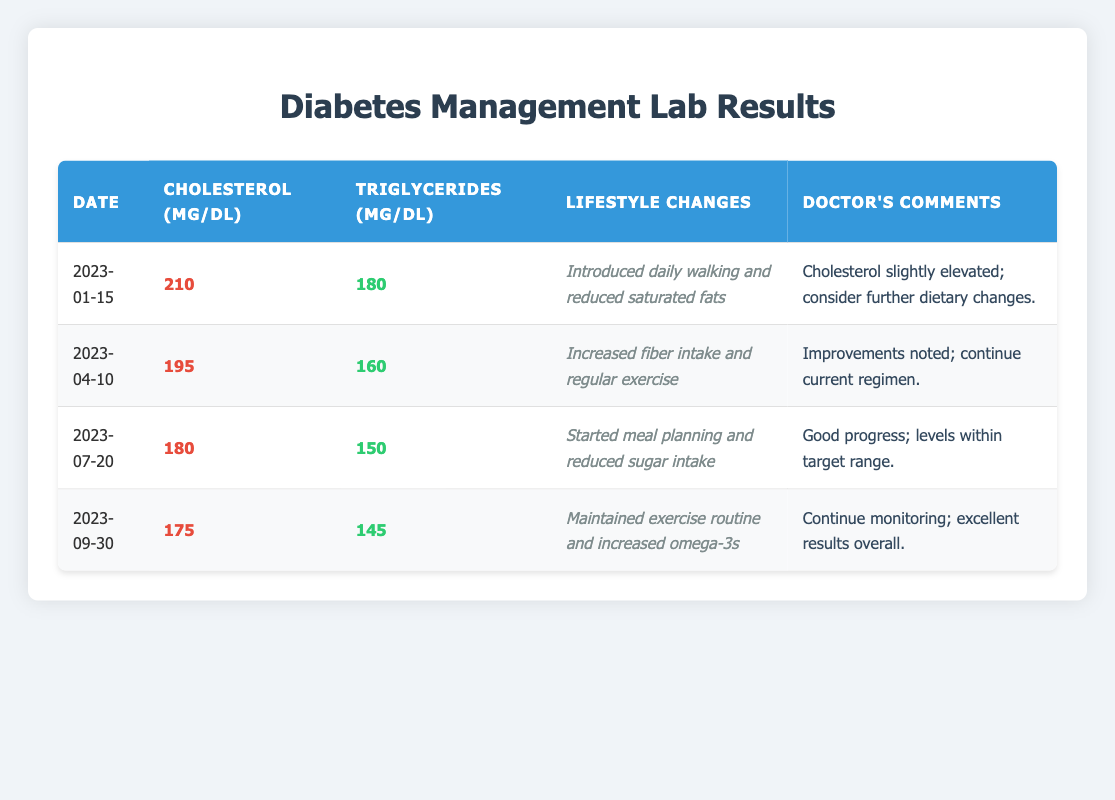What was the cholesterol level on January 15, 2023? Looking at the first row of the table, the cholesterol level recorded on January 15, 2023, is explicitly noted as 210 mg/dL.
Answer: 210 mg/dL What lifestyle changes were made on July 20, 2023? In the row for July 20, 2023, the lifestyle changes are stated to have been "Started meal planning and reduced sugar intake."
Answer: Started meal planning and reduced sugar intake What is the difference in triglyceride levels between April 10, 2023, and September 30, 2023? The triglyceride level on April 10, 2023, is 160 mg/dL, while on September 30, 2023, it is 145 mg/dL. Calculating the difference: 160 - 145 = 15 mg/dL.
Answer: 15 mg/dL Did cholesterol levels improve from January to July 2023? Comparing the cholesterol levels, January 15, 2023, shows 210 mg/dL and July 20, 2023, shows 180 mg/dL. Since 180 is less than 210, it indicates an improvement in cholesterol levels.
Answer: Yes What is the average cholesterol level across all four data points? Summing the cholesterol levels: 210 + 195 + 180 + 175 = 760 mg/dL. There are 4 measurements, so calculating the average gives 760 / 4 = 190 mg/dL.
Answer: 190 mg/dL Was there any doctor's comment regarding the levels on April 10, 2023? Yes, the comment from the doctor states "Improvements noted; continue current regimen," indicating a positive observation about the levels on that date.
Answer: Yes What was the trend in triglyceride levels from January to September 2023? The triglyceride levels were as follows: January: 180 mg/dL, April: 160 mg/dL, July: 150 mg/dL, September: 145 mg/dL. Observing the numbers, there is a consistent decrease, indicating an overall improvement.
Answer: Decreasing trend How much did cholesterol levels decrease from April 10 to July 20, 2023? The cholesterol level was 195 mg/dL on April 10, 2023, and decreased to 180 mg/dL on July 20, 2023. The decrease is calculated as 195 - 180 = 15 mg/dL.
Answer: 15 mg/dL 